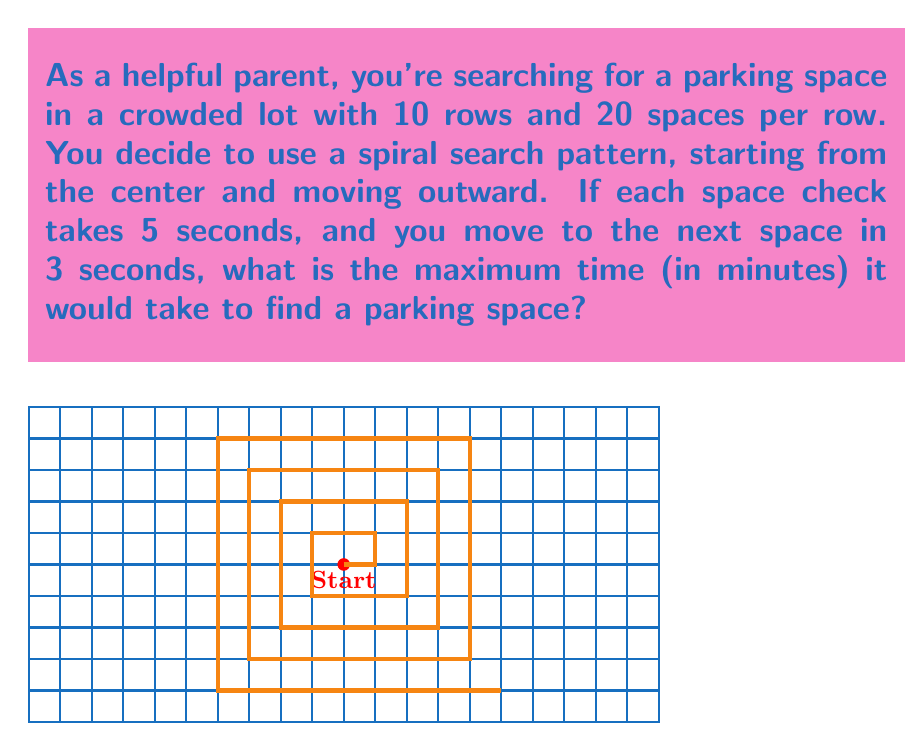Can you answer this question? Let's approach this step-by-step:

1) First, we need to calculate the total number of parking spaces:
   $$ \text{Total spaces} = 10 \text{ rows} \times 20 \text{ spaces per row} = 200 \text{ spaces} $$

2) In the worst-case scenario, we would need to check all spaces before finding an available one.

3) For each space, we spend:
   - 5 seconds to check if it's available
   - 3 seconds to move to the next space

4) So, the total time per space is:
   $$ \text{Time per space} = 5s + 3s = 8s $$

5) The total time to check all spaces would be:
   $$ \text{Total time} = 200 \text{ spaces} \times 8 \text{ seconds} = 1600 \text{ seconds} $$

6) To convert this to minutes:
   $$ \text{Time in minutes} = \frac{1600 \text{ seconds}}{60 \text{ seconds/minute}} = \frac{80}{3} \approx 26.67 \text{ minutes} $$

Therefore, the maximum time it would take to find a parking space is approximately 26.67 minutes.
Answer: $\frac{80}{3}$ minutes 